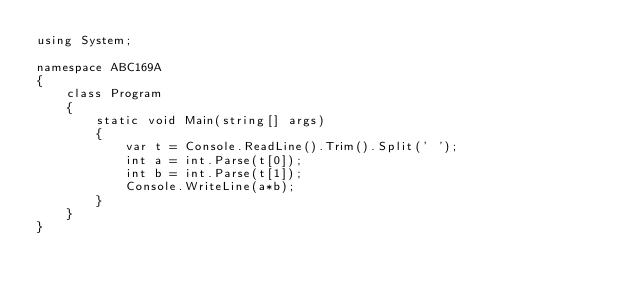<code> <loc_0><loc_0><loc_500><loc_500><_C#_>using System;

namespace ABC169A
{
    class Program
    {
        static void Main(string[] args)
        {
            var t = Console.ReadLine().Trim().Split(' ');
            int a = int.Parse(t[0]);
            int b = int.Parse(t[1]);
            Console.WriteLine(a*b);
        }
    }
}</code> 